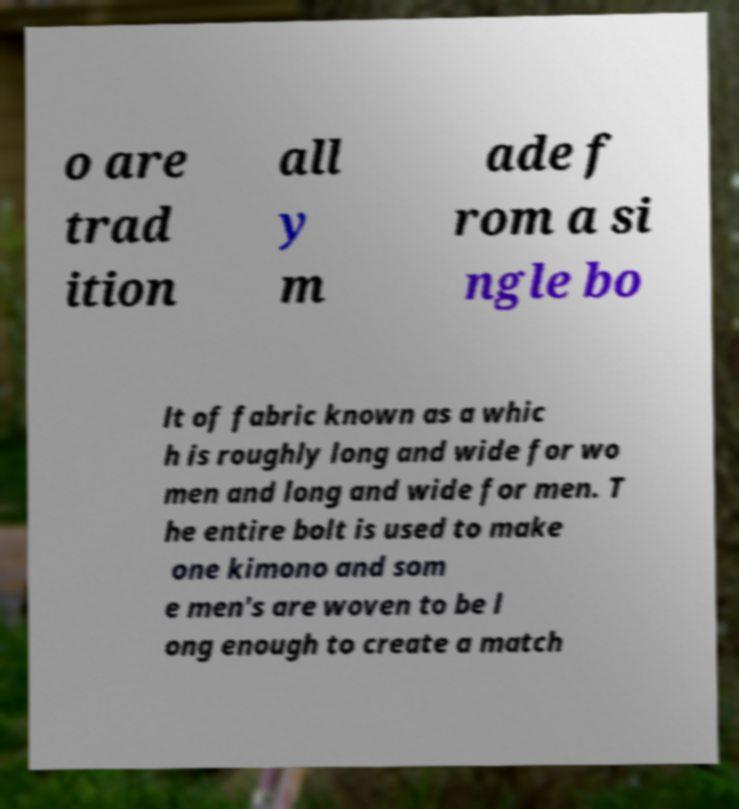Could you extract and type out the text from this image? o are trad ition all y m ade f rom a si ngle bo lt of fabric known as a whic h is roughly long and wide for wo men and long and wide for men. T he entire bolt is used to make one kimono and som e men's are woven to be l ong enough to create a match 